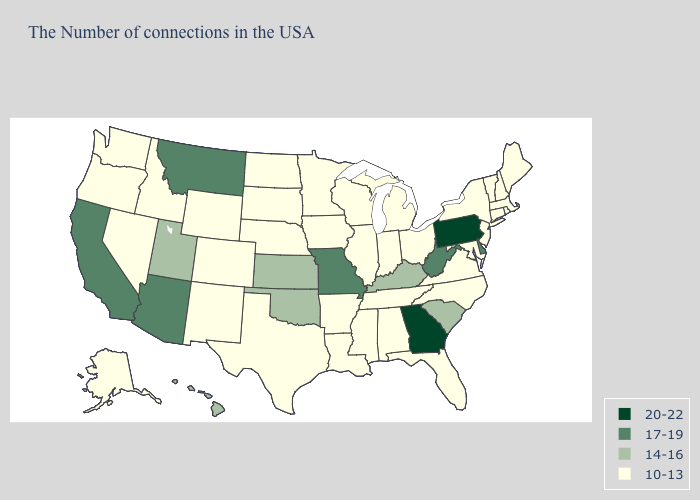Name the states that have a value in the range 17-19?
Quick response, please. Delaware, West Virginia, Missouri, Montana, Arizona, California. What is the value of Vermont?
Be succinct. 10-13. Does Louisiana have the lowest value in the South?
Be succinct. Yes. Does the first symbol in the legend represent the smallest category?
Short answer required. No. What is the value of Maryland?
Quick response, please. 10-13. What is the highest value in the Northeast ?
Concise answer only. 20-22. Name the states that have a value in the range 14-16?
Answer briefly. South Carolina, Kentucky, Kansas, Oklahoma, Utah, Hawaii. What is the value of New Mexico?
Be succinct. 10-13. What is the value of Alaska?
Give a very brief answer. 10-13. What is the highest value in the USA?
Keep it brief. 20-22. Which states have the highest value in the USA?
Quick response, please. Pennsylvania, Georgia. What is the lowest value in the USA?
Short answer required. 10-13. What is the lowest value in the USA?
Keep it brief. 10-13. Does Utah have the lowest value in the USA?
Answer briefly. No. Which states hav the highest value in the South?
Be succinct. Georgia. 